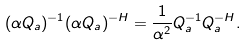<formula> <loc_0><loc_0><loc_500><loc_500>( \alpha Q _ { a } ) ^ { - 1 } ( \alpha Q _ { a } ) ^ { - H } = \frac { 1 } { \alpha ^ { 2 } } Q _ { a } ^ { - 1 } Q _ { a } ^ { - H } .</formula> 